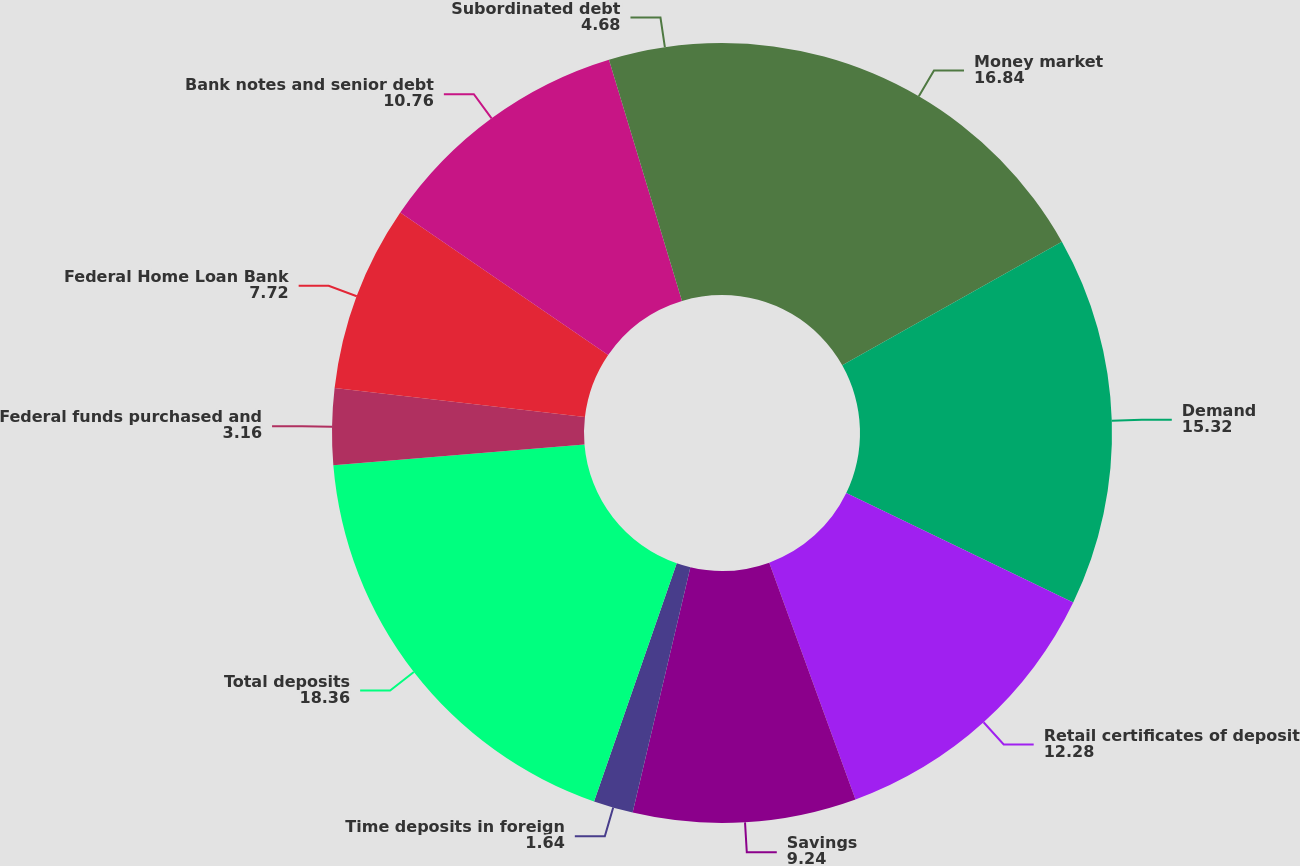<chart> <loc_0><loc_0><loc_500><loc_500><pie_chart><fcel>Money market<fcel>Demand<fcel>Retail certificates of deposit<fcel>Savings<fcel>Time deposits in foreign<fcel>Total deposits<fcel>Federal funds purchased and<fcel>Federal Home Loan Bank<fcel>Bank notes and senior debt<fcel>Subordinated debt<nl><fcel>16.84%<fcel>15.32%<fcel>12.28%<fcel>9.24%<fcel>1.64%<fcel>18.36%<fcel>3.16%<fcel>7.72%<fcel>10.76%<fcel>4.68%<nl></chart> 